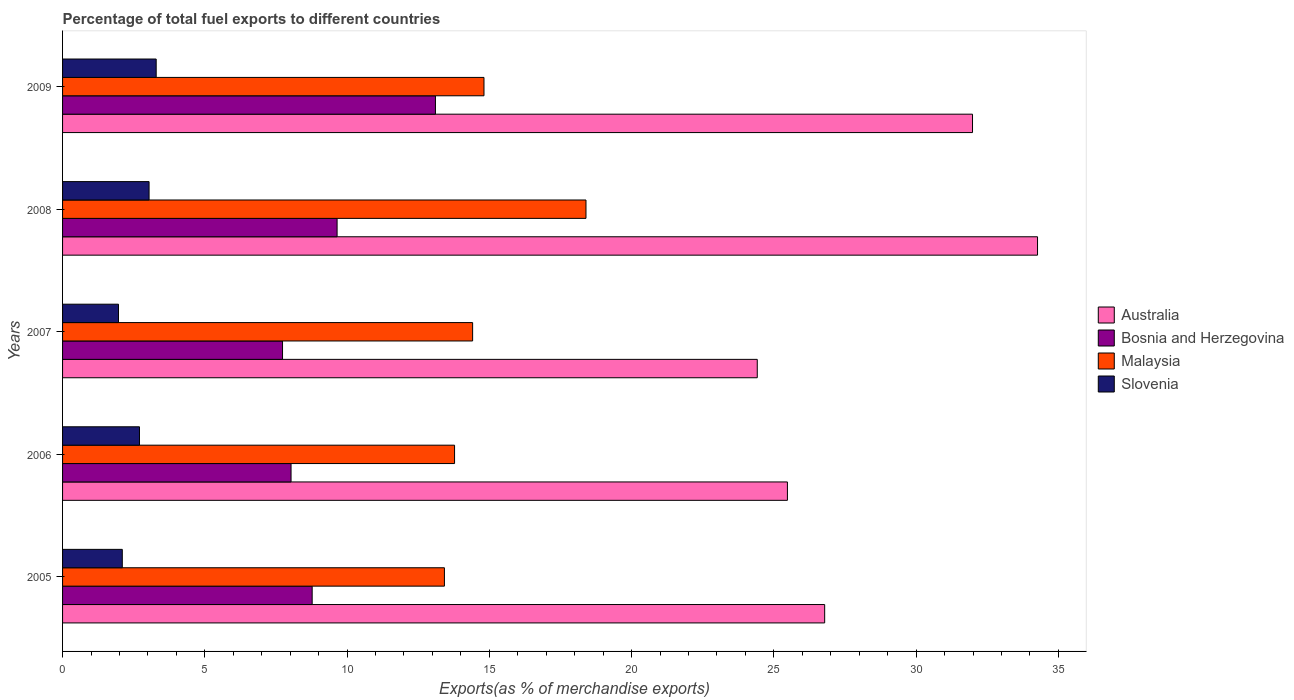How many different coloured bars are there?
Keep it short and to the point. 4. How many groups of bars are there?
Your answer should be compact. 5. Are the number of bars per tick equal to the number of legend labels?
Offer a terse response. Yes. How many bars are there on the 4th tick from the top?
Make the answer very short. 4. How many bars are there on the 2nd tick from the bottom?
Your response must be concise. 4. What is the percentage of exports to different countries in Slovenia in 2008?
Your answer should be compact. 3.04. Across all years, what is the maximum percentage of exports to different countries in Australia?
Provide a succinct answer. 34.27. Across all years, what is the minimum percentage of exports to different countries in Bosnia and Herzegovina?
Provide a succinct answer. 7.73. In which year was the percentage of exports to different countries in Malaysia maximum?
Provide a succinct answer. 2008. What is the total percentage of exports to different countries in Malaysia in the graph?
Provide a succinct answer. 74.82. What is the difference between the percentage of exports to different countries in Malaysia in 2005 and that in 2009?
Give a very brief answer. -1.39. What is the difference between the percentage of exports to different countries in Malaysia in 2005 and the percentage of exports to different countries in Australia in 2008?
Offer a very short reply. -20.85. What is the average percentage of exports to different countries in Malaysia per year?
Provide a short and direct response. 14.96. In the year 2005, what is the difference between the percentage of exports to different countries in Bosnia and Herzegovina and percentage of exports to different countries in Malaysia?
Ensure brevity in your answer.  -4.65. In how many years, is the percentage of exports to different countries in Bosnia and Herzegovina greater than 9 %?
Offer a terse response. 2. What is the ratio of the percentage of exports to different countries in Australia in 2006 to that in 2009?
Provide a succinct answer. 0.8. Is the difference between the percentage of exports to different countries in Bosnia and Herzegovina in 2005 and 2006 greater than the difference between the percentage of exports to different countries in Malaysia in 2005 and 2006?
Make the answer very short. Yes. What is the difference between the highest and the second highest percentage of exports to different countries in Bosnia and Herzegovina?
Keep it short and to the point. 3.46. What is the difference between the highest and the lowest percentage of exports to different countries in Slovenia?
Ensure brevity in your answer.  1.33. In how many years, is the percentage of exports to different countries in Malaysia greater than the average percentage of exports to different countries in Malaysia taken over all years?
Your answer should be compact. 1. Is the sum of the percentage of exports to different countries in Malaysia in 2006 and 2009 greater than the maximum percentage of exports to different countries in Australia across all years?
Offer a terse response. No. Is it the case that in every year, the sum of the percentage of exports to different countries in Malaysia and percentage of exports to different countries in Bosnia and Herzegovina is greater than the sum of percentage of exports to different countries in Australia and percentage of exports to different countries in Slovenia?
Provide a succinct answer. No. What does the 1st bar from the top in 2007 represents?
Your answer should be very brief. Slovenia. What does the 3rd bar from the bottom in 2005 represents?
Give a very brief answer. Malaysia. How many years are there in the graph?
Ensure brevity in your answer.  5. What is the difference between two consecutive major ticks on the X-axis?
Give a very brief answer. 5. Does the graph contain grids?
Give a very brief answer. No. Where does the legend appear in the graph?
Keep it short and to the point. Center right. How many legend labels are there?
Make the answer very short. 4. What is the title of the graph?
Keep it short and to the point. Percentage of total fuel exports to different countries. What is the label or title of the X-axis?
Give a very brief answer. Exports(as % of merchandise exports). What is the label or title of the Y-axis?
Ensure brevity in your answer.  Years. What is the Exports(as % of merchandise exports) of Australia in 2005?
Offer a terse response. 26.79. What is the Exports(as % of merchandise exports) in Bosnia and Herzegovina in 2005?
Your answer should be compact. 8.77. What is the Exports(as % of merchandise exports) in Malaysia in 2005?
Make the answer very short. 13.42. What is the Exports(as % of merchandise exports) in Slovenia in 2005?
Provide a short and direct response. 2.1. What is the Exports(as % of merchandise exports) in Australia in 2006?
Offer a very short reply. 25.48. What is the Exports(as % of merchandise exports) of Bosnia and Herzegovina in 2006?
Ensure brevity in your answer.  8.03. What is the Exports(as % of merchandise exports) of Malaysia in 2006?
Your answer should be compact. 13.78. What is the Exports(as % of merchandise exports) in Slovenia in 2006?
Provide a short and direct response. 2.7. What is the Exports(as % of merchandise exports) in Australia in 2007?
Your answer should be compact. 24.42. What is the Exports(as % of merchandise exports) in Bosnia and Herzegovina in 2007?
Your answer should be very brief. 7.73. What is the Exports(as % of merchandise exports) in Malaysia in 2007?
Your answer should be compact. 14.41. What is the Exports(as % of merchandise exports) of Slovenia in 2007?
Offer a very short reply. 1.97. What is the Exports(as % of merchandise exports) in Australia in 2008?
Ensure brevity in your answer.  34.27. What is the Exports(as % of merchandise exports) in Bosnia and Herzegovina in 2008?
Your answer should be compact. 9.65. What is the Exports(as % of merchandise exports) of Malaysia in 2008?
Offer a terse response. 18.4. What is the Exports(as % of merchandise exports) in Slovenia in 2008?
Give a very brief answer. 3.04. What is the Exports(as % of merchandise exports) in Australia in 2009?
Keep it short and to the point. 31.98. What is the Exports(as % of merchandise exports) in Bosnia and Herzegovina in 2009?
Your answer should be compact. 13.11. What is the Exports(as % of merchandise exports) in Malaysia in 2009?
Make the answer very short. 14.81. What is the Exports(as % of merchandise exports) in Slovenia in 2009?
Ensure brevity in your answer.  3.29. Across all years, what is the maximum Exports(as % of merchandise exports) of Australia?
Your answer should be very brief. 34.27. Across all years, what is the maximum Exports(as % of merchandise exports) of Bosnia and Herzegovina?
Your response must be concise. 13.11. Across all years, what is the maximum Exports(as % of merchandise exports) of Malaysia?
Your response must be concise. 18.4. Across all years, what is the maximum Exports(as % of merchandise exports) of Slovenia?
Your response must be concise. 3.29. Across all years, what is the minimum Exports(as % of merchandise exports) of Australia?
Ensure brevity in your answer.  24.42. Across all years, what is the minimum Exports(as % of merchandise exports) of Bosnia and Herzegovina?
Your answer should be very brief. 7.73. Across all years, what is the minimum Exports(as % of merchandise exports) of Malaysia?
Provide a succinct answer. 13.42. Across all years, what is the minimum Exports(as % of merchandise exports) in Slovenia?
Make the answer very short. 1.97. What is the total Exports(as % of merchandise exports) of Australia in the graph?
Give a very brief answer. 142.93. What is the total Exports(as % of merchandise exports) in Bosnia and Herzegovina in the graph?
Your answer should be compact. 47.29. What is the total Exports(as % of merchandise exports) of Malaysia in the graph?
Provide a short and direct response. 74.82. What is the total Exports(as % of merchandise exports) in Slovenia in the graph?
Offer a terse response. 13.1. What is the difference between the Exports(as % of merchandise exports) of Australia in 2005 and that in 2006?
Give a very brief answer. 1.31. What is the difference between the Exports(as % of merchandise exports) of Bosnia and Herzegovina in 2005 and that in 2006?
Ensure brevity in your answer.  0.74. What is the difference between the Exports(as % of merchandise exports) of Malaysia in 2005 and that in 2006?
Your answer should be compact. -0.36. What is the difference between the Exports(as % of merchandise exports) in Slovenia in 2005 and that in 2006?
Provide a succinct answer. -0.6. What is the difference between the Exports(as % of merchandise exports) in Australia in 2005 and that in 2007?
Provide a succinct answer. 2.37. What is the difference between the Exports(as % of merchandise exports) of Bosnia and Herzegovina in 2005 and that in 2007?
Your response must be concise. 1.04. What is the difference between the Exports(as % of merchandise exports) of Malaysia in 2005 and that in 2007?
Your response must be concise. -0.99. What is the difference between the Exports(as % of merchandise exports) of Slovenia in 2005 and that in 2007?
Your response must be concise. 0.13. What is the difference between the Exports(as % of merchandise exports) of Australia in 2005 and that in 2008?
Your answer should be very brief. -7.48. What is the difference between the Exports(as % of merchandise exports) of Bosnia and Herzegovina in 2005 and that in 2008?
Offer a terse response. -0.88. What is the difference between the Exports(as % of merchandise exports) of Malaysia in 2005 and that in 2008?
Give a very brief answer. -4.98. What is the difference between the Exports(as % of merchandise exports) in Slovenia in 2005 and that in 2008?
Your answer should be compact. -0.94. What is the difference between the Exports(as % of merchandise exports) of Australia in 2005 and that in 2009?
Your answer should be compact. -5.2. What is the difference between the Exports(as % of merchandise exports) of Bosnia and Herzegovina in 2005 and that in 2009?
Offer a very short reply. -4.33. What is the difference between the Exports(as % of merchandise exports) of Malaysia in 2005 and that in 2009?
Provide a short and direct response. -1.39. What is the difference between the Exports(as % of merchandise exports) of Slovenia in 2005 and that in 2009?
Provide a succinct answer. -1.19. What is the difference between the Exports(as % of merchandise exports) in Australia in 2006 and that in 2007?
Make the answer very short. 1.06. What is the difference between the Exports(as % of merchandise exports) in Bosnia and Herzegovina in 2006 and that in 2007?
Make the answer very short. 0.3. What is the difference between the Exports(as % of merchandise exports) in Malaysia in 2006 and that in 2007?
Provide a succinct answer. -0.63. What is the difference between the Exports(as % of merchandise exports) of Slovenia in 2006 and that in 2007?
Give a very brief answer. 0.74. What is the difference between the Exports(as % of merchandise exports) of Australia in 2006 and that in 2008?
Keep it short and to the point. -8.79. What is the difference between the Exports(as % of merchandise exports) in Bosnia and Herzegovina in 2006 and that in 2008?
Your answer should be very brief. -1.62. What is the difference between the Exports(as % of merchandise exports) in Malaysia in 2006 and that in 2008?
Your answer should be very brief. -4.62. What is the difference between the Exports(as % of merchandise exports) of Slovenia in 2006 and that in 2008?
Your answer should be compact. -0.34. What is the difference between the Exports(as % of merchandise exports) in Australia in 2006 and that in 2009?
Ensure brevity in your answer.  -6.51. What is the difference between the Exports(as % of merchandise exports) of Bosnia and Herzegovina in 2006 and that in 2009?
Give a very brief answer. -5.08. What is the difference between the Exports(as % of merchandise exports) of Malaysia in 2006 and that in 2009?
Keep it short and to the point. -1.03. What is the difference between the Exports(as % of merchandise exports) of Slovenia in 2006 and that in 2009?
Provide a succinct answer. -0.59. What is the difference between the Exports(as % of merchandise exports) in Australia in 2007 and that in 2008?
Give a very brief answer. -9.85. What is the difference between the Exports(as % of merchandise exports) in Bosnia and Herzegovina in 2007 and that in 2008?
Provide a succinct answer. -1.92. What is the difference between the Exports(as % of merchandise exports) in Malaysia in 2007 and that in 2008?
Your answer should be compact. -3.98. What is the difference between the Exports(as % of merchandise exports) of Slovenia in 2007 and that in 2008?
Give a very brief answer. -1.08. What is the difference between the Exports(as % of merchandise exports) of Australia in 2007 and that in 2009?
Your answer should be compact. -7.57. What is the difference between the Exports(as % of merchandise exports) in Bosnia and Herzegovina in 2007 and that in 2009?
Your answer should be compact. -5.37. What is the difference between the Exports(as % of merchandise exports) in Malaysia in 2007 and that in 2009?
Your response must be concise. -0.4. What is the difference between the Exports(as % of merchandise exports) of Slovenia in 2007 and that in 2009?
Ensure brevity in your answer.  -1.33. What is the difference between the Exports(as % of merchandise exports) of Australia in 2008 and that in 2009?
Your answer should be very brief. 2.29. What is the difference between the Exports(as % of merchandise exports) of Bosnia and Herzegovina in 2008 and that in 2009?
Ensure brevity in your answer.  -3.46. What is the difference between the Exports(as % of merchandise exports) of Malaysia in 2008 and that in 2009?
Offer a terse response. 3.58. What is the difference between the Exports(as % of merchandise exports) of Slovenia in 2008 and that in 2009?
Offer a terse response. -0.25. What is the difference between the Exports(as % of merchandise exports) in Australia in 2005 and the Exports(as % of merchandise exports) in Bosnia and Herzegovina in 2006?
Keep it short and to the point. 18.76. What is the difference between the Exports(as % of merchandise exports) of Australia in 2005 and the Exports(as % of merchandise exports) of Malaysia in 2006?
Your answer should be compact. 13.01. What is the difference between the Exports(as % of merchandise exports) of Australia in 2005 and the Exports(as % of merchandise exports) of Slovenia in 2006?
Offer a very short reply. 24.08. What is the difference between the Exports(as % of merchandise exports) of Bosnia and Herzegovina in 2005 and the Exports(as % of merchandise exports) of Malaysia in 2006?
Provide a short and direct response. -5. What is the difference between the Exports(as % of merchandise exports) of Bosnia and Herzegovina in 2005 and the Exports(as % of merchandise exports) of Slovenia in 2006?
Ensure brevity in your answer.  6.07. What is the difference between the Exports(as % of merchandise exports) of Malaysia in 2005 and the Exports(as % of merchandise exports) of Slovenia in 2006?
Your response must be concise. 10.72. What is the difference between the Exports(as % of merchandise exports) in Australia in 2005 and the Exports(as % of merchandise exports) in Bosnia and Herzegovina in 2007?
Ensure brevity in your answer.  19.05. What is the difference between the Exports(as % of merchandise exports) in Australia in 2005 and the Exports(as % of merchandise exports) in Malaysia in 2007?
Give a very brief answer. 12.37. What is the difference between the Exports(as % of merchandise exports) of Australia in 2005 and the Exports(as % of merchandise exports) of Slovenia in 2007?
Keep it short and to the point. 24.82. What is the difference between the Exports(as % of merchandise exports) of Bosnia and Herzegovina in 2005 and the Exports(as % of merchandise exports) of Malaysia in 2007?
Provide a succinct answer. -5.64. What is the difference between the Exports(as % of merchandise exports) of Bosnia and Herzegovina in 2005 and the Exports(as % of merchandise exports) of Slovenia in 2007?
Offer a very short reply. 6.81. What is the difference between the Exports(as % of merchandise exports) of Malaysia in 2005 and the Exports(as % of merchandise exports) of Slovenia in 2007?
Provide a succinct answer. 11.46. What is the difference between the Exports(as % of merchandise exports) in Australia in 2005 and the Exports(as % of merchandise exports) in Bosnia and Herzegovina in 2008?
Provide a succinct answer. 17.14. What is the difference between the Exports(as % of merchandise exports) in Australia in 2005 and the Exports(as % of merchandise exports) in Malaysia in 2008?
Your answer should be compact. 8.39. What is the difference between the Exports(as % of merchandise exports) of Australia in 2005 and the Exports(as % of merchandise exports) of Slovenia in 2008?
Your answer should be compact. 23.75. What is the difference between the Exports(as % of merchandise exports) in Bosnia and Herzegovina in 2005 and the Exports(as % of merchandise exports) in Malaysia in 2008?
Your answer should be compact. -9.62. What is the difference between the Exports(as % of merchandise exports) in Bosnia and Herzegovina in 2005 and the Exports(as % of merchandise exports) in Slovenia in 2008?
Offer a terse response. 5.73. What is the difference between the Exports(as % of merchandise exports) of Malaysia in 2005 and the Exports(as % of merchandise exports) of Slovenia in 2008?
Provide a short and direct response. 10.38. What is the difference between the Exports(as % of merchandise exports) in Australia in 2005 and the Exports(as % of merchandise exports) in Bosnia and Herzegovina in 2009?
Provide a succinct answer. 13.68. What is the difference between the Exports(as % of merchandise exports) of Australia in 2005 and the Exports(as % of merchandise exports) of Malaysia in 2009?
Provide a short and direct response. 11.97. What is the difference between the Exports(as % of merchandise exports) of Australia in 2005 and the Exports(as % of merchandise exports) of Slovenia in 2009?
Make the answer very short. 23.5. What is the difference between the Exports(as % of merchandise exports) of Bosnia and Herzegovina in 2005 and the Exports(as % of merchandise exports) of Malaysia in 2009?
Your response must be concise. -6.04. What is the difference between the Exports(as % of merchandise exports) of Bosnia and Herzegovina in 2005 and the Exports(as % of merchandise exports) of Slovenia in 2009?
Your answer should be very brief. 5.48. What is the difference between the Exports(as % of merchandise exports) of Malaysia in 2005 and the Exports(as % of merchandise exports) of Slovenia in 2009?
Provide a short and direct response. 10.13. What is the difference between the Exports(as % of merchandise exports) in Australia in 2006 and the Exports(as % of merchandise exports) in Bosnia and Herzegovina in 2007?
Your response must be concise. 17.75. What is the difference between the Exports(as % of merchandise exports) in Australia in 2006 and the Exports(as % of merchandise exports) in Malaysia in 2007?
Ensure brevity in your answer.  11.06. What is the difference between the Exports(as % of merchandise exports) in Australia in 2006 and the Exports(as % of merchandise exports) in Slovenia in 2007?
Provide a short and direct response. 23.51. What is the difference between the Exports(as % of merchandise exports) in Bosnia and Herzegovina in 2006 and the Exports(as % of merchandise exports) in Malaysia in 2007?
Offer a very short reply. -6.38. What is the difference between the Exports(as % of merchandise exports) of Bosnia and Herzegovina in 2006 and the Exports(as % of merchandise exports) of Slovenia in 2007?
Your answer should be very brief. 6.07. What is the difference between the Exports(as % of merchandise exports) in Malaysia in 2006 and the Exports(as % of merchandise exports) in Slovenia in 2007?
Your response must be concise. 11.81. What is the difference between the Exports(as % of merchandise exports) of Australia in 2006 and the Exports(as % of merchandise exports) of Bosnia and Herzegovina in 2008?
Keep it short and to the point. 15.83. What is the difference between the Exports(as % of merchandise exports) in Australia in 2006 and the Exports(as % of merchandise exports) in Malaysia in 2008?
Keep it short and to the point. 7.08. What is the difference between the Exports(as % of merchandise exports) of Australia in 2006 and the Exports(as % of merchandise exports) of Slovenia in 2008?
Provide a succinct answer. 22.44. What is the difference between the Exports(as % of merchandise exports) in Bosnia and Herzegovina in 2006 and the Exports(as % of merchandise exports) in Malaysia in 2008?
Provide a succinct answer. -10.37. What is the difference between the Exports(as % of merchandise exports) in Bosnia and Herzegovina in 2006 and the Exports(as % of merchandise exports) in Slovenia in 2008?
Ensure brevity in your answer.  4.99. What is the difference between the Exports(as % of merchandise exports) in Malaysia in 2006 and the Exports(as % of merchandise exports) in Slovenia in 2008?
Make the answer very short. 10.74. What is the difference between the Exports(as % of merchandise exports) in Australia in 2006 and the Exports(as % of merchandise exports) in Bosnia and Herzegovina in 2009?
Your answer should be very brief. 12.37. What is the difference between the Exports(as % of merchandise exports) of Australia in 2006 and the Exports(as % of merchandise exports) of Malaysia in 2009?
Make the answer very short. 10.66. What is the difference between the Exports(as % of merchandise exports) of Australia in 2006 and the Exports(as % of merchandise exports) of Slovenia in 2009?
Provide a short and direct response. 22.19. What is the difference between the Exports(as % of merchandise exports) of Bosnia and Herzegovina in 2006 and the Exports(as % of merchandise exports) of Malaysia in 2009?
Make the answer very short. -6.78. What is the difference between the Exports(as % of merchandise exports) in Bosnia and Herzegovina in 2006 and the Exports(as % of merchandise exports) in Slovenia in 2009?
Ensure brevity in your answer.  4.74. What is the difference between the Exports(as % of merchandise exports) of Malaysia in 2006 and the Exports(as % of merchandise exports) of Slovenia in 2009?
Your answer should be very brief. 10.49. What is the difference between the Exports(as % of merchandise exports) in Australia in 2007 and the Exports(as % of merchandise exports) in Bosnia and Herzegovina in 2008?
Keep it short and to the point. 14.77. What is the difference between the Exports(as % of merchandise exports) in Australia in 2007 and the Exports(as % of merchandise exports) in Malaysia in 2008?
Your answer should be very brief. 6.02. What is the difference between the Exports(as % of merchandise exports) of Australia in 2007 and the Exports(as % of merchandise exports) of Slovenia in 2008?
Your answer should be very brief. 21.38. What is the difference between the Exports(as % of merchandise exports) in Bosnia and Herzegovina in 2007 and the Exports(as % of merchandise exports) in Malaysia in 2008?
Your answer should be very brief. -10.67. What is the difference between the Exports(as % of merchandise exports) in Bosnia and Herzegovina in 2007 and the Exports(as % of merchandise exports) in Slovenia in 2008?
Offer a very short reply. 4.69. What is the difference between the Exports(as % of merchandise exports) of Malaysia in 2007 and the Exports(as % of merchandise exports) of Slovenia in 2008?
Make the answer very short. 11.37. What is the difference between the Exports(as % of merchandise exports) in Australia in 2007 and the Exports(as % of merchandise exports) in Bosnia and Herzegovina in 2009?
Your response must be concise. 11.31. What is the difference between the Exports(as % of merchandise exports) of Australia in 2007 and the Exports(as % of merchandise exports) of Malaysia in 2009?
Make the answer very short. 9.6. What is the difference between the Exports(as % of merchandise exports) of Australia in 2007 and the Exports(as % of merchandise exports) of Slovenia in 2009?
Offer a very short reply. 21.13. What is the difference between the Exports(as % of merchandise exports) of Bosnia and Herzegovina in 2007 and the Exports(as % of merchandise exports) of Malaysia in 2009?
Give a very brief answer. -7.08. What is the difference between the Exports(as % of merchandise exports) in Bosnia and Herzegovina in 2007 and the Exports(as % of merchandise exports) in Slovenia in 2009?
Give a very brief answer. 4.44. What is the difference between the Exports(as % of merchandise exports) of Malaysia in 2007 and the Exports(as % of merchandise exports) of Slovenia in 2009?
Your response must be concise. 11.12. What is the difference between the Exports(as % of merchandise exports) of Australia in 2008 and the Exports(as % of merchandise exports) of Bosnia and Herzegovina in 2009?
Keep it short and to the point. 21.16. What is the difference between the Exports(as % of merchandise exports) of Australia in 2008 and the Exports(as % of merchandise exports) of Malaysia in 2009?
Your answer should be very brief. 19.46. What is the difference between the Exports(as % of merchandise exports) in Australia in 2008 and the Exports(as % of merchandise exports) in Slovenia in 2009?
Ensure brevity in your answer.  30.98. What is the difference between the Exports(as % of merchandise exports) in Bosnia and Herzegovina in 2008 and the Exports(as % of merchandise exports) in Malaysia in 2009?
Give a very brief answer. -5.16. What is the difference between the Exports(as % of merchandise exports) of Bosnia and Herzegovina in 2008 and the Exports(as % of merchandise exports) of Slovenia in 2009?
Provide a short and direct response. 6.36. What is the difference between the Exports(as % of merchandise exports) in Malaysia in 2008 and the Exports(as % of merchandise exports) in Slovenia in 2009?
Your answer should be very brief. 15.11. What is the average Exports(as % of merchandise exports) in Australia per year?
Make the answer very short. 28.59. What is the average Exports(as % of merchandise exports) of Bosnia and Herzegovina per year?
Ensure brevity in your answer.  9.46. What is the average Exports(as % of merchandise exports) in Malaysia per year?
Offer a terse response. 14.96. What is the average Exports(as % of merchandise exports) in Slovenia per year?
Offer a very short reply. 2.62. In the year 2005, what is the difference between the Exports(as % of merchandise exports) of Australia and Exports(as % of merchandise exports) of Bosnia and Herzegovina?
Keep it short and to the point. 18.01. In the year 2005, what is the difference between the Exports(as % of merchandise exports) in Australia and Exports(as % of merchandise exports) in Malaysia?
Offer a very short reply. 13.36. In the year 2005, what is the difference between the Exports(as % of merchandise exports) of Australia and Exports(as % of merchandise exports) of Slovenia?
Offer a very short reply. 24.69. In the year 2005, what is the difference between the Exports(as % of merchandise exports) in Bosnia and Herzegovina and Exports(as % of merchandise exports) in Malaysia?
Make the answer very short. -4.65. In the year 2005, what is the difference between the Exports(as % of merchandise exports) in Bosnia and Herzegovina and Exports(as % of merchandise exports) in Slovenia?
Provide a short and direct response. 6.67. In the year 2005, what is the difference between the Exports(as % of merchandise exports) in Malaysia and Exports(as % of merchandise exports) in Slovenia?
Provide a short and direct response. 11.32. In the year 2006, what is the difference between the Exports(as % of merchandise exports) in Australia and Exports(as % of merchandise exports) in Bosnia and Herzegovina?
Your answer should be very brief. 17.45. In the year 2006, what is the difference between the Exports(as % of merchandise exports) in Australia and Exports(as % of merchandise exports) in Malaysia?
Make the answer very short. 11.7. In the year 2006, what is the difference between the Exports(as % of merchandise exports) in Australia and Exports(as % of merchandise exports) in Slovenia?
Offer a very short reply. 22.77. In the year 2006, what is the difference between the Exports(as % of merchandise exports) of Bosnia and Herzegovina and Exports(as % of merchandise exports) of Malaysia?
Make the answer very short. -5.75. In the year 2006, what is the difference between the Exports(as % of merchandise exports) of Bosnia and Herzegovina and Exports(as % of merchandise exports) of Slovenia?
Provide a short and direct response. 5.33. In the year 2006, what is the difference between the Exports(as % of merchandise exports) in Malaysia and Exports(as % of merchandise exports) in Slovenia?
Your response must be concise. 11.07. In the year 2007, what is the difference between the Exports(as % of merchandise exports) of Australia and Exports(as % of merchandise exports) of Bosnia and Herzegovina?
Ensure brevity in your answer.  16.69. In the year 2007, what is the difference between the Exports(as % of merchandise exports) in Australia and Exports(as % of merchandise exports) in Malaysia?
Your answer should be very brief. 10. In the year 2007, what is the difference between the Exports(as % of merchandise exports) of Australia and Exports(as % of merchandise exports) of Slovenia?
Provide a succinct answer. 22.45. In the year 2007, what is the difference between the Exports(as % of merchandise exports) in Bosnia and Herzegovina and Exports(as % of merchandise exports) in Malaysia?
Offer a terse response. -6.68. In the year 2007, what is the difference between the Exports(as % of merchandise exports) in Bosnia and Herzegovina and Exports(as % of merchandise exports) in Slovenia?
Your answer should be compact. 5.77. In the year 2007, what is the difference between the Exports(as % of merchandise exports) of Malaysia and Exports(as % of merchandise exports) of Slovenia?
Offer a very short reply. 12.45. In the year 2008, what is the difference between the Exports(as % of merchandise exports) of Australia and Exports(as % of merchandise exports) of Bosnia and Herzegovina?
Ensure brevity in your answer.  24.62. In the year 2008, what is the difference between the Exports(as % of merchandise exports) of Australia and Exports(as % of merchandise exports) of Malaysia?
Your answer should be very brief. 15.87. In the year 2008, what is the difference between the Exports(as % of merchandise exports) of Australia and Exports(as % of merchandise exports) of Slovenia?
Ensure brevity in your answer.  31.23. In the year 2008, what is the difference between the Exports(as % of merchandise exports) in Bosnia and Herzegovina and Exports(as % of merchandise exports) in Malaysia?
Provide a short and direct response. -8.75. In the year 2008, what is the difference between the Exports(as % of merchandise exports) of Bosnia and Herzegovina and Exports(as % of merchandise exports) of Slovenia?
Your answer should be very brief. 6.61. In the year 2008, what is the difference between the Exports(as % of merchandise exports) in Malaysia and Exports(as % of merchandise exports) in Slovenia?
Provide a short and direct response. 15.36. In the year 2009, what is the difference between the Exports(as % of merchandise exports) of Australia and Exports(as % of merchandise exports) of Bosnia and Herzegovina?
Provide a succinct answer. 18.88. In the year 2009, what is the difference between the Exports(as % of merchandise exports) of Australia and Exports(as % of merchandise exports) of Malaysia?
Offer a very short reply. 17.17. In the year 2009, what is the difference between the Exports(as % of merchandise exports) of Australia and Exports(as % of merchandise exports) of Slovenia?
Keep it short and to the point. 28.69. In the year 2009, what is the difference between the Exports(as % of merchandise exports) in Bosnia and Herzegovina and Exports(as % of merchandise exports) in Malaysia?
Offer a terse response. -1.71. In the year 2009, what is the difference between the Exports(as % of merchandise exports) in Bosnia and Herzegovina and Exports(as % of merchandise exports) in Slovenia?
Give a very brief answer. 9.82. In the year 2009, what is the difference between the Exports(as % of merchandise exports) in Malaysia and Exports(as % of merchandise exports) in Slovenia?
Your response must be concise. 11.52. What is the ratio of the Exports(as % of merchandise exports) of Australia in 2005 to that in 2006?
Your response must be concise. 1.05. What is the ratio of the Exports(as % of merchandise exports) of Bosnia and Herzegovina in 2005 to that in 2006?
Keep it short and to the point. 1.09. What is the ratio of the Exports(as % of merchandise exports) of Malaysia in 2005 to that in 2006?
Ensure brevity in your answer.  0.97. What is the ratio of the Exports(as % of merchandise exports) of Slovenia in 2005 to that in 2006?
Ensure brevity in your answer.  0.78. What is the ratio of the Exports(as % of merchandise exports) in Australia in 2005 to that in 2007?
Make the answer very short. 1.1. What is the ratio of the Exports(as % of merchandise exports) in Bosnia and Herzegovina in 2005 to that in 2007?
Give a very brief answer. 1.13. What is the ratio of the Exports(as % of merchandise exports) in Malaysia in 2005 to that in 2007?
Your answer should be very brief. 0.93. What is the ratio of the Exports(as % of merchandise exports) in Slovenia in 2005 to that in 2007?
Your answer should be very brief. 1.07. What is the ratio of the Exports(as % of merchandise exports) of Australia in 2005 to that in 2008?
Offer a very short reply. 0.78. What is the ratio of the Exports(as % of merchandise exports) of Bosnia and Herzegovina in 2005 to that in 2008?
Your answer should be very brief. 0.91. What is the ratio of the Exports(as % of merchandise exports) in Malaysia in 2005 to that in 2008?
Make the answer very short. 0.73. What is the ratio of the Exports(as % of merchandise exports) of Slovenia in 2005 to that in 2008?
Offer a very short reply. 0.69. What is the ratio of the Exports(as % of merchandise exports) in Australia in 2005 to that in 2009?
Offer a very short reply. 0.84. What is the ratio of the Exports(as % of merchandise exports) in Bosnia and Herzegovina in 2005 to that in 2009?
Ensure brevity in your answer.  0.67. What is the ratio of the Exports(as % of merchandise exports) of Malaysia in 2005 to that in 2009?
Your answer should be very brief. 0.91. What is the ratio of the Exports(as % of merchandise exports) of Slovenia in 2005 to that in 2009?
Ensure brevity in your answer.  0.64. What is the ratio of the Exports(as % of merchandise exports) in Australia in 2006 to that in 2007?
Your answer should be compact. 1.04. What is the ratio of the Exports(as % of merchandise exports) in Bosnia and Herzegovina in 2006 to that in 2007?
Provide a short and direct response. 1.04. What is the ratio of the Exports(as % of merchandise exports) of Malaysia in 2006 to that in 2007?
Provide a succinct answer. 0.96. What is the ratio of the Exports(as % of merchandise exports) of Slovenia in 2006 to that in 2007?
Give a very brief answer. 1.38. What is the ratio of the Exports(as % of merchandise exports) in Australia in 2006 to that in 2008?
Your response must be concise. 0.74. What is the ratio of the Exports(as % of merchandise exports) in Bosnia and Herzegovina in 2006 to that in 2008?
Provide a succinct answer. 0.83. What is the ratio of the Exports(as % of merchandise exports) of Malaysia in 2006 to that in 2008?
Your response must be concise. 0.75. What is the ratio of the Exports(as % of merchandise exports) in Slovenia in 2006 to that in 2008?
Your answer should be very brief. 0.89. What is the ratio of the Exports(as % of merchandise exports) of Australia in 2006 to that in 2009?
Ensure brevity in your answer.  0.8. What is the ratio of the Exports(as % of merchandise exports) in Bosnia and Herzegovina in 2006 to that in 2009?
Provide a short and direct response. 0.61. What is the ratio of the Exports(as % of merchandise exports) of Malaysia in 2006 to that in 2009?
Keep it short and to the point. 0.93. What is the ratio of the Exports(as % of merchandise exports) in Slovenia in 2006 to that in 2009?
Make the answer very short. 0.82. What is the ratio of the Exports(as % of merchandise exports) of Australia in 2007 to that in 2008?
Ensure brevity in your answer.  0.71. What is the ratio of the Exports(as % of merchandise exports) in Bosnia and Herzegovina in 2007 to that in 2008?
Provide a short and direct response. 0.8. What is the ratio of the Exports(as % of merchandise exports) in Malaysia in 2007 to that in 2008?
Provide a succinct answer. 0.78. What is the ratio of the Exports(as % of merchandise exports) of Slovenia in 2007 to that in 2008?
Offer a terse response. 0.65. What is the ratio of the Exports(as % of merchandise exports) of Australia in 2007 to that in 2009?
Offer a terse response. 0.76. What is the ratio of the Exports(as % of merchandise exports) of Bosnia and Herzegovina in 2007 to that in 2009?
Your answer should be compact. 0.59. What is the ratio of the Exports(as % of merchandise exports) of Slovenia in 2007 to that in 2009?
Give a very brief answer. 0.6. What is the ratio of the Exports(as % of merchandise exports) of Australia in 2008 to that in 2009?
Make the answer very short. 1.07. What is the ratio of the Exports(as % of merchandise exports) of Bosnia and Herzegovina in 2008 to that in 2009?
Give a very brief answer. 0.74. What is the ratio of the Exports(as % of merchandise exports) in Malaysia in 2008 to that in 2009?
Your answer should be very brief. 1.24. What is the ratio of the Exports(as % of merchandise exports) in Slovenia in 2008 to that in 2009?
Your answer should be compact. 0.92. What is the difference between the highest and the second highest Exports(as % of merchandise exports) in Australia?
Give a very brief answer. 2.29. What is the difference between the highest and the second highest Exports(as % of merchandise exports) in Bosnia and Herzegovina?
Make the answer very short. 3.46. What is the difference between the highest and the second highest Exports(as % of merchandise exports) in Malaysia?
Your response must be concise. 3.58. What is the difference between the highest and the second highest Exports(as % of merchandise exports) in Slovenia?
Make the answer very short. 0.25. What is the difference between the highest and the lowest Exports(as % of merchandise exports) of Australia?
Give a very brief answer. 9.85. What is the difference between the highest and the lowest Exports(as % of merchandise exports) in Bosnia and Herzegovina?
Offer a terse response. 5.37. What is the difference between the highest and the lowest Exports(as % of merchandise exports) of Malaysia?
Ensure brevity in your answer.  4.98. What is the difference between the highest and the lowest Exports(as % of merchandise exports) of Slovenia?
Offer a terse response. 1.33. 